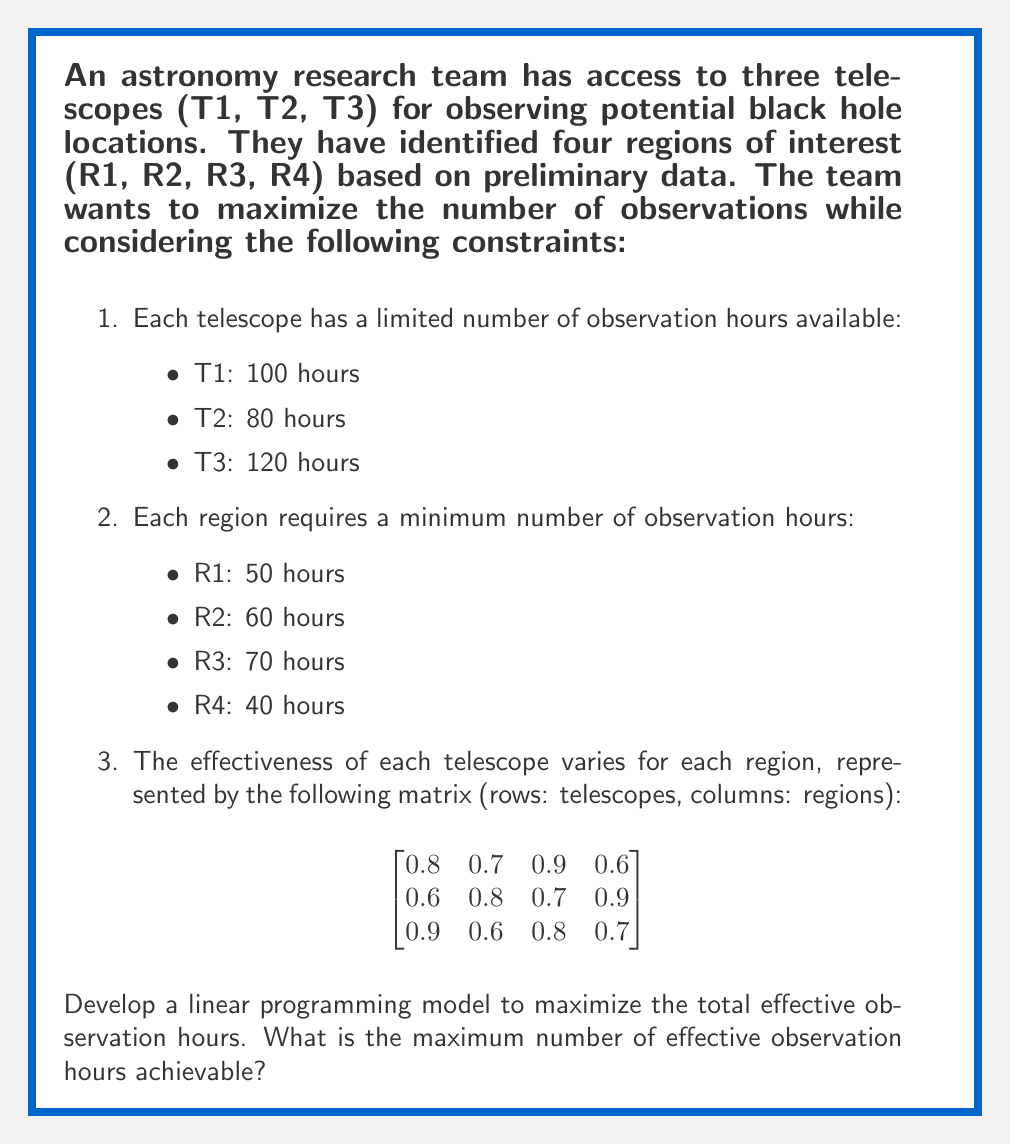Can you solve this math problem? To solve this problem, we need to formulate a linear programming model and then solve it. Let's break it down step by step:

1. Define decision variables:
   Let $x_{ij}$ be the number of hours telescope i spends observing region j.

2. Objective function:
   Maximize the total effective observation hours:
   $$ \text{Max } Z = 0.8x_{11} + 0.7x_{12} + 0.9x_{13} + 0.6x_{14} + 0.6x_{21} + 0.8x_{22} + 0.7x_{23} + 0.9x_{24} + 0.9x_{31} + 0.6x_{32} + 0.8x_{33} + 0.7x_{34} $$

3. Constraints:
   a) Telescope time limits:
      $$ x_{11} + x_{12} + x_{13} + x_{14} \leq 100 $$
      $$ x_{21} + x_{22} + x_{23} + x_{24} \leq 80 $$
      $$ x_{31} + x_{32} + x_{33} + x_{34} \leq 120 $$

   b) Minimum observation hours for each region:
      $$ x_{11} + x_{21} + x_{31} \geq 50 $$
      $$ x_{12} + x_{22} + x_{32} \geq 60 $$
      $$ x_{13} + x_{23} + x_{33} \geq 70 $$
      $$ x_{14} + x_{24} + x_{34} \geq 40 $$

   c) Non-negativity constraints:
      $$ x_{ij} \geq 0 \text{ for all } i \text{ and } j $$

4. Solve the linear programming model:
   Using a linear programming solver (e.g., simplex method), we can find the optimal solution.

5. Interpret the results:
   The solver will provide the optimal values for each $x_{ij}$ and the maximum value of Z.

For this specific problem, solving the linear programming model yields the following optimal solution:

$$ \begin{aligned}
x_{11} &= 0, x_{12} = 0, x_{13} = 100, x_{14} = 0 \\
x_{21} &= 0, x_{22} = 60, x_{23} = 0, x_{24} = 20 \\
x_{31} &= 50, x_{32} = 0, x_{33} = 0, x_{34} = 70
\end{aligned} $$

Substituting these values into the objective function:

$$ \begin{aligned}
Z &= 0.8(0) + 0.7(0) + 0.9(100) + 0.6(0) \\
  &+ 0.6(0) + 0.8(60) + 0.7(0) + 0.9(20) \\
  &+ 0.9(50) + 0.6(0) + 0.8(0) + 0.7(70) \\
  &= 90 + 48 + 18 + 45 + 49 \\
  &= 250
\end{aligned} $$

Therefore, the maximum number of effective observation hours achievable is 250.
Answer: The maximum number of effective observation hours achievable is 250. 